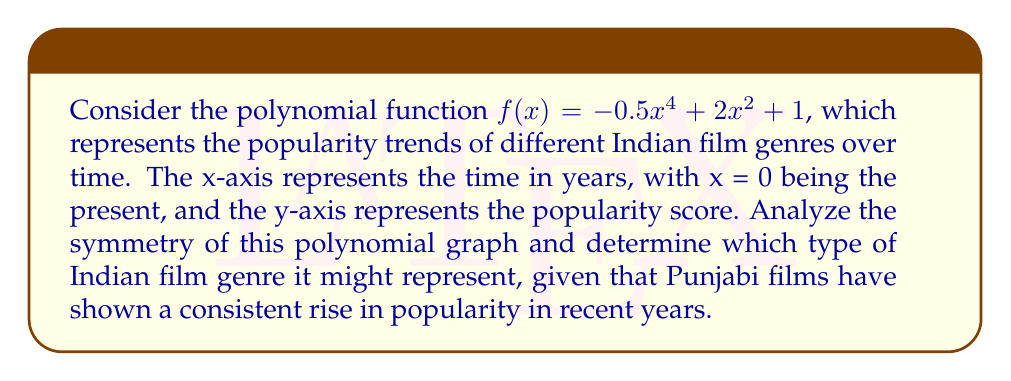Give your solution to this math problem. To analyze the symmetry of the polynomial graph, we need to follow these steps:

1. Identify the degree of the polynomial:
   The polynomial $f(x) = -0.5x^4 + 2x^2 + 1$ is of degree 4 (even).

2. Examine the coefficients:
   - The coefficient of $x^4$ is negative (-0.5)
   - There is no $x^3$ or $x$ term
   - The coefficient of $x^2$ is positive (2)
   - There is a constant term (1)

3. Determine the y-intercept:
   When x = 0, $f(0) = 1$, so the y-intercept is (0, 1).

4. Analyze the end behavior:
   As $x \to \pm\infty$, $-0.5x^4$ dominates, so $f(x) \to -\infty$ in both directions.

5. Check for symmetry:
   The function only contains even powers of x ($x^4$ and $x^2$), which means it is symmetric about the y-axis. This can be verified by checking if $f(x) = f(-x)$ for all x:
   
   $f(x) = -0.5x^4 + 2x^2 + 1$
   $f(-x) = -0.5(-x)^4 + 2(-x)^2 + 1 = -0.5x^4 + 2x^2 + 1$

   Since $f(x) = f(-x)$, the function is indeed symmetric about the y-axis.

6. Sketch the graph:
   The graph will have a shape similar to a wider, inverted "W" with the center peak at (0, 1) and two symmetric valleys on either side.

Given that Punjabi films have shown a consistent rise in popularity in recent years, this graph is unlikely to represent that trend. Instead, it might represent a genre that had high popularity in the past, declined, and is now experiencing a resurgence. This could potentially represent the trend of classical or traditional Indian film genres that are making a comeback in modern cinema.
Answer: The polynomial graph $f(x) = -0.5x^4 + 2x^2 + 1$ is symmetric about the y-axis. It likely represents a traditional or classical Indian film genre experiencing a resurgence, rather than the consistently rising popularity of Punjabi films. 